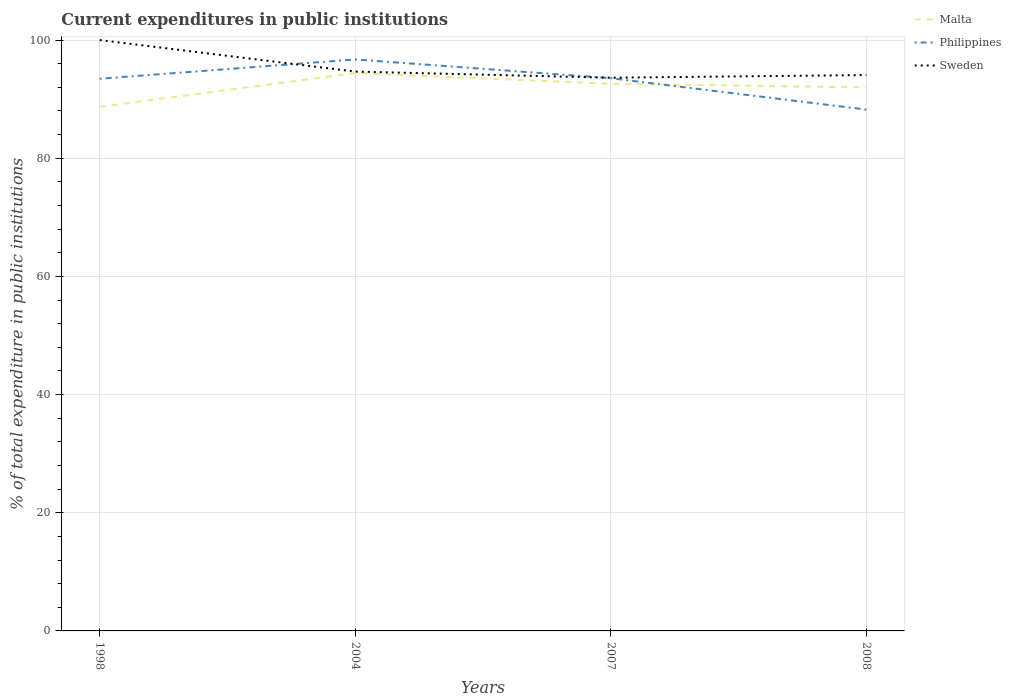Across all years, what is the maximum current expenditures in public institutions in Sweden?
Provide a succinct answer. 93.62. What is the total current expenditures in public institutions in Malta in the graph?
Your answer should be compact. -3.29. What is the difference between the highest and the second highest current expenditures in public institutions in Philippines?
Your answer should be compact. 8.49. What is the difference between the highest and the lowest current expenditures in public institutions in Malta?
Your answer should be compact. 3. Are the values on the major ticks of Y-axis written in scientific E-notation?
Ensure brevity in your answer.  No. Does the graph contain grids?
Offer a terse response. Yes. How many legend labels are there?
Make the answer very short. 3. What is the title of the graph?
Provide a succinct answer. Current expenditures in public institutions. What is the label or title of the X-axis?
Make the answer very short. Years. What is the label or title of the Y-axis?
Ensure brevity in your answer.  % of total expenditure in public institutions. What is the % of total expenditure in public institutions of Malta in 1998?
Offer a very short reply. 88.7. What is the % of total expenditure in public institutions in Philippines in 1998?
Make the answer very short. 93.45. What is the % of total expenditure in public institutions of Sweden in 1998?
Keep it short and to the point. 100. What is the % of total expenditure in public institutions in Malta in 2004?
Give a very brief answer. 94.42. What is the % of total expenditure in public institutions of Philippines in 2004?
Keep it short and to the point. 96.72. What is the % of total expenditure in public institutions in Sweden in 2004?
Provide a succinct answer. 94.66. What is the % of total expenditure in public institutions in Malta in 2007?
Make the answer very short. 92.6. What is the % of total expenditure in public institutions in Philippines in 2007?
Your answer should be very brief. 93.54. What is the % of total expenditure in public institutions of Sweden in 2007?
Offer a very short reply. 93.62. What is the % of total expenditure in public institutions in Malta in 2008?
Make the answer very short. 91.99. What is the % of total expenditure in public institutions of Philippines in 2008?
Offer a very short reply. 88.23. What is the % of total expenditure in public institutions of Sweden in 2008?
Provide a succinct answer. 94.08. Across all years, what is the maximum % of total expenditure in public institutions in Malta?
Your answer should be compact. 94.42. Across all years, what is the maximum % of total expenditure in public institutions of Philippines?
Your answer should be compact. 96.72. Across all years, what is the minimum % of total expenditure in public institutions of Malta?
Keep it short and to the point. 88.7. Across all years, what is the minimum % of total expenditure in public institutions in Philippines?
Offer a terse response. 88.23. Across all years, what is the minimum % of total expenditure in public institutions in Sweden?
Your response must be concise. 93.62. What is the total % of total expenditure in public institutions in Malta in the graph?
Your response must be concise. 367.7. What is the total % of total expenditure in public institutions of Philippines in the graph?
Offer a terse response. 371.94. What is the total % of total expenditure in public institutions of Sweden in the graph?
Provide a succinct answer. 382.36. What is the difference between the % of total expenditure in public institutions of Malta in 1998 and that in 2004?
Your response must be concise. -5.72. What is the difference between the % of total expenditure in public institutions of Philippines in 1998 and that in 2004?
Give a very brief answer. -3.27. What is the difference between the % of total expenditure in public institutions in Sweden in 1998 and that in 2004?
Your answer should be compact. 5.34. What is the difference between the % of total expenditure in public institutions in Malta in 1998 and that in 2007?
Provide a short and direct response. -3.9. What is the difference between the % of total expenditure in public institutions of Philippines in 1998 and that in 2007?
Your answer should be very brief. -0.09. What is the difference between the % of total expenditure in public institutions in Sweden in 1998 and that in 2007?
Ensure brevity in your answer.  6.38. What is the difference between the % of total expenditure in public institutions in Malta in 1998 and that in 2008?
Make the answer very short. -3.29. What is the difference between the % of total expenditure in public institutions of Philippines in 1998 and that in 2008?
Provide a succinct answer. 5.22. What is the difference between the % of total expenditure in public institutions of Sweden in 1998 and that in 2008?
Keep it short and to the point. 5.92. What is the difference between the % of total expenditure in public institutions of Malta in 2004 and that in 2007?
Provide a short and direct response. 1.82. What is the difference between the % of total expenditure in public institutions in Philippines in 2004 and that in 2007?
Make the answer very short. 3.18. What is the difference between the % of total expenditure in public institutions in Sweden in 2004 and that in 2007?
Provide a short and direct response. 1.04. What is the difference between the % of total expenditure in public institutions of Malta in 2004 and that in 2008?
Your answer should be very brief. 2.43. What is the difference between the % of total expenditure in public institutions in Philippines in 2004 and that in 2008?
Provide a short and direct response. 8.49. What is the difference between the % of total expenditure in public institutions of Sweden in 2004 and that in 2008?
Your answer should be compact. 0.59. What is the difference between the % of total expenditure in public institutions in Malta in 2007 and that in 2008?
Provide a succinct answer. 0.61. What is the difference between the % of total expenditure in public institutions of Philippines in 2007 and that in 2008?
Your answer should be very brief. 5.31. What is the difference between the % of total expenditure in public institutions in Sweden in 2007 and that in 2008?
Make the answer very short. -0.45. What is the difference between the % of total expenditure in public institutions of Malta in 1998 and the % of total expenditure in public institutions of Philippines in 2004?
Provide a succinct answer. -8.02. What is the difference between the % of total expenditure in public institutions of Malta in 1998 and the % of total expenditure in public institutions of Sweden in 2004?
Ensure brevity in your answer.  -5.97. What is the difference between the % of total expenditure in public institutions in Philippines in 1998 and the % of total expenditure in public institutions in Sweden in 2004?
Offer a terse response. -1.21. What is the difference between the % of total expenditure in public institutions of Malta in 1998 and the % of total expenditure in public institutions of Philippines in 2007?
Your answer should be compact. -4.84. What is the difference between the % of total expenditure in public institutions in Malta in 1998 and the % of total expenditure in public institutions in Sweden in 2007?
Ensure brevity in your answer.  -4.93. What is the difference between the % of total expenditure in public institutions of Philippines in 1998 and the % of total expenditure in public institutions of Sweden in 2007?
Your response must be concise. -0.17. What is the difference between the % of total expenditure in public institutions of Malta in 1998 and the % of total expenditure in public institutions of Philippines in 2008?
Your answer should be compact. 0.46. What is the difference between the % of total expenditure in public institutions in Malta in 1998 and the % of total expenditure in public institutions in Sweden in 2008?
Ensure brevity in your answer.  -5.38. What is the difference between the % of total expenditure in public institutions of Philippines in 1998 and the % of total expenditure in public institutions of Sweden in 2008?
Provide a short and direct response. -0.62. What is the difference between the % of total expenditure in public institutions of Malta in 2004 and the % of total expenditure in public institutions of Philippines in 2007?
Provide a succinct answer. 0.88. What is the difference between the % of total expenditure in public institutions in Malta in 2004 and the % of total expenditure in public institutions in Sweden in 2007?
Ensure brevity in your answer.  0.79. What is the difference between the % of total expenditure in public institutions of Philippines in 2004 and the % of total expenditure in public institutions of Sweden in 2007?
Keep it short and to the point. 3.1. What is the difference between the % of total expenditure in public institutions in Malta in 2004 and the % of total expenditure in public institutions in Philippines in 2008?
Offer a terse response. 6.19. What is the difference between the % of total expenditure in public institutions in Malta in 2004 and the % of total expenditure in public institutions in Sweden in 2008?
Offer a very short reply. 0.34. What is the difference between the % of total expenditure in public institutions in Philippines in 2004 and the % of total expenditure in public institutions in Sweden in 2008?
Give a very brief answer. 2.64. What is the difference between the % of total expenditure in public institutions in Malta in 2007 and the % of total expenditure in public institutions in Philippines in 2008?
Keep it short and to the point. 4.37. What is the difference between the % of total expenditure in public institutions of Malta in 2007 and the % of total expenditure in public institutions of Sweden in 2008?
Your answer should be very brief. -1.48. What is the difference between the % of total expenditure in public institutions of Philippines in 2007 and the % of total expenditure in public institutions of Sweden in 2008?
Provide a short and direct response. -0.54. What is the average % of total expenditure in public institutions of Malta per year?
Provide a succinct answer. 91.92. What is the average % of total expenditure in public institutions of Philippines per year?
Your answer should be very brief. 92.99. What is the average % of total expenditure in public institutions of Sweden per year?
Provide a short and direct response. 95.59. In the year 1998, what is the difference between the % of total expenditure in public institutions in Malta and % of total expenditure in public institutions in Philippines?
Offer a very short reply. -4.76. In the year 1998, what is the difference between the % of total expenditure in public institutions in Malta and % of total expenditure in public institutions in Sweden?
Offer a terse response. -11.3. In the year 1998, what is the difference between the % of total expenditure in public institutions of Philippines and % of total expenditure in public institutions of Sweden?
Make the answer very short. -6.55. In the year 2004, what is the difference between the % of total expenditure in public institutions in Malta and % of total expenditure in public institutions in Philippines?
Offer a very short reply. -2.3. In the year 2004, what is the difference between the % of total expenditure in public institutions in Malta and % of total expenditure in public institutions in Sweden?
Your answer should be compact. -0.24. In the year 2004, what is the difference between the % of total expenditure in public institutions in Philippines and % of total expenditure in public institutions in Sweden?
Provide a succinct answer. 2.06. In the year 2007, what is the difference between the % of total expenditure in public institutions of Malta and % of total expenditure in public institutions of Philippines?
Ensure brevity in your answer.  -0.94. In the year 2007, what is the difference between the % of total expenditure in public institutions in Malta and % of total expenditure in public institutions in Sweden?
Provide a succinct answer. -1.02. In the year 2007, what is the difference between the % of total expenditure in public institutions of Philippines and % of total expenditure in public institutions of Sweden?
Keep it short and to the point. -0.08. In the year 2008, what is the difference between the % of total expenditure in public institutions of Malta and % of total expenditure in public institutions of Philippines?
Make the answer very short. 3.75. In the year 2008, what is the difference between the % of total expenditure in public institutions of Malta and % of total expenditure in public institutions of Sweden?
Give a very brief answer. -2.09. In the year 2008, what is the difference between the % of total expenditure in public institutions in Philippines and % of total expenditure in public institutions in Sweden?
Provide a succinct answer. -5.85. What is the ratio of the % of total expenditure in public institutions of Malta in 1998 to that in 2004?
Provide a succinct answer. 0.94. What is the ratio of the % of total expenditure in public institutions of Philippines in 1998 to that in 2004?
Provide a succinct answer. 0.97. What is the ratio of the % of total expenditure in public institutions of Sweden in 1998 to that in 2004?
Provide a short and direct response. 1.06. What is the ratio of the % of total expenditure in public institutions in Malta in 1998 to that in 2007?
Provide a short and direct response. 0.96. What is the ratio of the % of total expenditure in public institutions in Sweden in 1998 to that in 2007?
Give a very brief answer. 1.07. What is the ratio of the % of total expenditure in public institutions of Malta in 1998 to that in 2008?
Provide a short and direct response. 0.96. What is the ratio of the % of total expenditure in public institutions of Philippines in 1998 to that in 2008?
Your response must be concise. 1.06. What is the ratio of the % of total expenditure in public institutions of Sweden in 1998 to that in 2008?
Offer a terse response. 1.06. What is the ratio of the % of total expenditure in public institutions of Malta in 2004 to that in 2007?
Your answer should be compact. 1.02. What is the ratio of the % of total expenditure in public institutions of Philippines in 2004 to that in 2007?
Your answer should be very brief. 1.03. What is the ratio of the % of total expenditure in public institutions in Sweden in 2004 to that in 2007?
Your answer should be very brief. 1.01. What is the ratio of the % of total expenditure in public institutions of Malta in 2004 to that in 2008?
Offer a very short reply. 1.03. What is the ratio of the % of total expenditure in public institutions in Philippines in 2004 to that in 2008?
Provide a short and direct response. 1.1. What is the ratio of the % of total expenditure in public institutions of Sweden in 2004 to that in 2008?
Offer a terse response. 1.01. What is the ratio of the % of total expenditure in public institutions in Malta in 2007 to that in 2008?
Provide a succinct answer. 1.01. What is the ratio of the % of total expenditure in public institutions in Philippines in 2007 to that in 2008?
Offer a terse response. 1.06. What is the difference between the highest and the second highest % of total expenditure in public institutions in Malta?
Your answer should be compact. 1.82. What is the difference between the highest and the second highest % of total expenditure in public institutions of Philippines?
Make the answer very short. 3.18. What is the difference between the highest and the second highest % of total expenditure in public institutions in Sweden?
Your answer should be compact. 5.34. What is the difference between the highest and the lowest % of total expenditure in public institutions of Malta?
Provide a short and direct response. 5.72. What is the difference between the highest and the lowest % of total expenditure in public institutions in Philippines?
Your response must be concise. 8.49. What is the difference between the highest and the lowest % of total expenditure in public institutions of Sweden?
Ensure brevity in your answer.  6.38. 